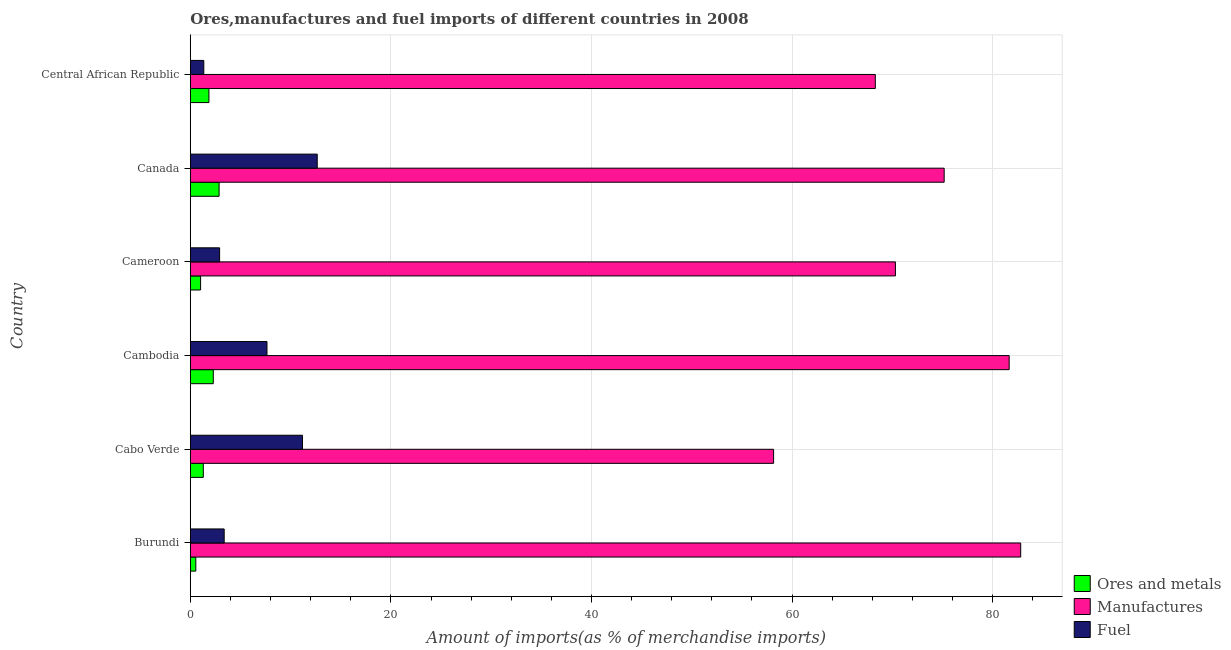How many groups of bars are there?
Offer a terse response. 6. Are the number of bars per tick equal to the number of legend labels?
Provide a succinct answer. Yes. How many bars are there on the 5th tick from the top?
Provide a short and direct response. 3. How many bars are there on the 1st tick from the bottom?
Ensure brevity in your answer.  3. What is the label of the 6th group of bars from the top?
Offer a terse response. Burundi. What is the percentage of fuel imports in Burundi?
Offer a very short reply. 3.38. Across all countries, what is the maximum percentage of manufactures imports?
Make the answer very short. 82.8. Across all countries, what is the minimum percentage of manufactures imports?
Provide a short and direct response. 58.16. In which country was the percentage of manufactures imports maximum?
Your answer should be very brief. Burundi. In which country was the percentage of fuel imports minimum?
Provide a short and direct response. Central African Republic. What is the total percentage of fuel imports in the graph?
Provide a succinct answer. 39.14. What is the difference between the percentage of fuel imports in Burundi and that in Cabo Verde?
Ensure brevity in your answer.  -7.81. What is the difference between the percentage of manufactures imports in Central African Republic and the percentage of ores and metals imports in Canada?
Offer a very short reply. 65.43. What is the average percentage of fuel imports per country?
Your answer should be very brief. 6.52. What is the difference between the percentage of ores and metals imports and percentage of manufactures imports in Cabo Verde?
Your response must be concise. -56.86. What is the ratio of the percentage of manufactures imports in Burundi to that in Cabo Verde?
Give a very brief answer. 1.42. Is the percentage of fuel imports in Cameroon less than that in Central African Republic?
Give a very brief answer. No. Is the difference between the percentage of manufactures imports in Burundi and Cameroon greater than the difference between the percentage of ores and metals imports in Burundi and Cameroon?
Your response must be concise. Yes. What is the difference between the highest and the second highest percentage of fuel imports?
Your response must be concise. 1.47. What is the difference between the highest and the lowest percentage of manufactures imports?
Provide a succinct answer. 24.64. What does the 3rd bar from the top in Canada represents?
Ensure brevity in your answer.  Ores and metals. What does the 3rd bar from the bottom in Canada represents?
Provide a succinct answer. Fuel. Is it the case that in every country, the sum of the percentage of ores and metals imports and percentage of manufactures imports is greater than the percentage of fuel imports?
Your answer should be very brief. Yes. Are all the bars in the graph horizontal?
Your answer should be compact. Yes. What is the difference between two consecutive major ticks on the X-axis?
Keep it short and to the point. 20. Are the values on the major ticks of X-axis written in scientific E-notation?
Offer a very short reply. No. Does the graph contain any zero values?
Your response must be concise. No. What is the title of the graph?
Offer a terse response. Ores,manufactures and fuel imports of different countries in 2008. Does "Oil sources" appear as one of the legend labels in the graph?
Your response must be concise. No. What is the label or title of the X-axis?
Provide a succinct answer. Amount of imports(as % of merchandise imports). What is the Amount of imports(as % of merchandise imports) of Ores and metals in Burundi?
Provide a short and direct response. 0.55. What is the Amount of imports(as % of merchandise imports) of Manufactures in Burundi?
Your answer should be compact. 82.8. What is the Amount of imports(as % of merchandise imports) in Fuel in Burundi?
Offer a terse response. 3.38. What is the Amount of imports(as % of merchandise imports) in Ores and metals in Cabo Verde?
Offer a very short reply. 1.3. What is the Amount of imports(as % of merchandise imports) of Manufactures in Cabo Verde?
Your answer should be compact. 58.16. What is the Amount of imports(as % of merchandise imports) in Fuel in Cabo Verde?
Keep it short and to the point. 11.19. What is the Amount of imports(as % of merchandise imports) in Ores and metals in Cambodia?
Make the answer very short. 2.29. What is the Amount of imports(as % of merchandise imports) in Manufactures in Cambodia?
Your answer should be very brief. 81.65. What is the Amount of imports(as % of merchandise imports) of Fuel in Cambodia?
Your response must be concise. 7.65. What is the Amount of imports(as % of merchandise imports) of Ores and metals in Cameroon?
Make the answer very short. 1.03. What is the Amount of imports(as % of merchandise imports) in Manufactures in Cameroon?
Your response must be concise. 70.31. What is the Amount of imports(as % of merchandise imports) in Fuel in Cameroon?
Ensure brevity in your answer.  2.92. What is the Amount of imports(as % of merchandise imports) in Ores and metals in Canada?
Your answer should be compact. 2.87. What is the Amount of imports(as % of merchandise imports) in Manufactures in Canada?
Keep it short and to the point. 75.17. What is the Amount of imports(as % of merchandise imports) of Fuel in Canada?
Keep it short and to the point. 12.66. What is the Amount of imports(as % of merchandise imports) in Ores and metals in Central African Republic?
Make the answer very short. 1.86. What is the Amount of imports(as % of merchandise imports) in Manufactures in Central African Republic?
Make the answer very short. 68.3. What is the Amount of imports(as % of merchandise imports) in Fuel in Central African Republic?
Provide a short and direct response. 1.35. Across all countries, what is the maximum Amount of imports(as % of merchandise imports) of Ores and metals?
Give a very brief answer. 2.87. Across all countries, what is the maximum Amount of imports(as % of merchandise imports) in Manufactures?
Provide a short and direct response. 82.8. Across all countries, what is the maximum Amount of imports(as % of merchandise imports) in Fuel?
Give a very brief answer. 12.66. Across all countries, what is the minimum Amount of imports(as % of merchandise imports) in Ores and metals?
Make the answer very short. 0.55. Across all countries, what is the minimum Amount of imports(as % of merchandise imports) of Manufactures?
Offer a very short reply. 58.16. Across all countries, what is the minimum Amount of imports(as % of merchandise imports) in Fuel?
Offer a terse response. 1.35. What is the total Amount of imports(as % of merchandise imports) in Ores and metals in the graph?
Offer a terse response. 9.9. What is the total Amount of imports(as % of merchandise imports) of Manufactures in the graph?
Keep it short and to the point. 436.39. What is the total Amount of imports(as % of merchandise imports) of Fuel in the graph?
Provide a succinct answer. 39.14. What is the difference between the Amount of imports(as % of merchandise imports) in Ores and metals in Burundi and that in Cabo Verde?
Your answer should be compact. -0.75. What is the difference between the Amount of imports(as % of merchandise imports) in Manufactures in Burundi and that in Cabo Verde?
Make the answer very short. 24.64. What is the difference between the Amount of imports(as % of merchandise imports) in Fuel in Burundi and that in Cabo Verde?
Provide a succinct answer. -7.81. What is the difference between the Amount of imports(as % of merchandise imports) in Ores and metals in Burundi and that in Cambodia?
Make the answer very short. -1.74. What is the difference between the Amount of imports(as % of merchandise imports) of Manufactures in Burundi and that in Cambodia?
Ensure brevity in your answer.  1.15. What is the difference between the Amount of imports(as % of merchandise imports) of Fuel in Burundi and that in Cambodia?
Offer a terse response. -4.27. What is the difference between the Amount of imports(as % of merchandise imports) in Ores and metals in Burundi and that in Cameroon?
Provide a succinct answer. -0.48. What is the difference between the Amount of imports(as % of merchandise imports) of Manufactures in Burundi and that in Cameroon?
Your answer should be compact. 12.49. What is the difference between the Amount of imports(as % of merchandise imports) in Fuel in Burundi and that in Cameroon?
Keep it short and to the point. 0.46. What is the difference between the Amount of imports(as % of merchandise imports) in Ores and metals in Burundi and that in Canada?
Give a very brief answer. -2.32. What is the difference between the Amount of imports(as % of merchandise imports) in Manufactures in Burundi and that in Canada?
Your answer should be very brief. 7.63. What is the difference between the Amount of imports(as % of merchandise imports) in Fuel in Burundi and that in Canada?
Your response must be concise. -9.28. What is the difference between the Amount of imports(as % of merchandise imports) in Ores and metals in Burundi and that in Central African Republic?
Your answer should be compact. -1.31. What is the difference between the Amount of imports(as % of merchandise imports) in Manufactures in Burundi and that in Central African Republic?
Keep it short and to the point. 14.49. What is the difference between the Amount of imports(as % of merchandise imports) of Fuel in Burundi and that in Central African Republic?
Provide a succinct answer. 2.03. What is the difference between the Amount of imports(as % of merchandise imports) in Ores and metals in Cabo Verde and that in Cambodia?
Offer a very short reply. -0.99. What is the difference between the Amount of imports(as % of merchandise imports) of Manufactures in Cabo Verde and that in Cambodia?
Give a very brief answer. -23.49. What is the difference between the Amount of imports(as % of merchandise imports) of Fuel in Cabo Verde and that in Cambodia?
Your response must be concise. 3.54. What is the difference between the Amount of imports(as % of merchandise imports) of Ores and metals in Cabo Verde and that in Cameroon?
Your response must be concise. 0.27. What is the difference between the Amount of imports(as % of merchandise imports) of Manufactures in Cabo Verde and that in Cameroon?
Make the answer very short. -12.15. What is the difference between the Amount of imports(as % of merchandise imports) in Fuel in Cabo Verde and that in Cameroon?
Provide a short and direct response. 8.26. What is the difference between the Amount of imports(as % of merchandise imports) in Ores and metals in Cabo Verde and that in Canada?
Offer a terse response. -1.57. What is the difference between the Amount of imports(as % of merchandise imports) in Manufactures in Cabo Verde and that in Canada?
Your response must be concise. -17.01. What is the difference between the Amount of imports(as % of merchandise imports) in Fuel in Cabo Verde and that in Canada?
Provide a short and direct response. -1.47. What is the difference between the Amount of imports(as % of merchandise imports) in Ores and metals in Cabo Verde and that in Central African Republic?
Give a very brief answer. -0.56. What is the difference between the Amount of imports(as % of merchandise imports) in Manufactures in Cabo Verde and that in Central African Republic?
Ensure brevity in your answer.  -10.14. What is the difference between the Amount of imports(as % of merchandise imports) of Fuel in Cabo Verde and that in Central African Republic?
Your answer should be compact. 9.84. What is the difference between the Amount of imports(as % of merchandise imports) of Ores and metals in Cambodia and that in Cameroon?
Your answer should be very brief. 1.27. What is the difference between the Amount of imports(as % of merchandise imports) in Manufactures in Cambodia and that in Cameroon?
Your answer should be compact. 11.34. What is the difference between the Amount of imports(as % of merchandise imports) of Fuel in Cambodia and that in Cameroon?
Ensure brevity in your answer.  4.72. What is the difference between the Amount of imports(as % of merchandise imports) in Ores and metals in Cambodia and that in Canada?
Offer a very short reply. -0.58. What is the difference between the Amount of imports(as % of merchandise imports) in Manufactures in Cambodia and that in Canada?
Offer a very short reply. 6.48. What is the difference between the Amount of imports(as % of merchandise imports) of Fuel in Cambodia and that in Canada?
Provide a succinct answer. -5.01. What is the difference between the Amount of imports(as % of merchandise imports) of Ores and metals in Cambodia and that in Central African Republic?
Your response must be concise. 0.44. What is the difference between the Amount of imports(as % of merchandise imports) of Manufactures in Cambodia and that in Central African Republic?
Offer a terse response. 13.34. What is the difference between the Amount of imports(as % of merchandise imports) in Fuel in Cambodia and that in Central African Republic?
Provide a short and direct response. 6.3. What is the difference between the Amount of imports(as % of merchandise imports) in Ores and metals in Cameroon and that in Canada?
Give a very brief answer. -1.85. What is the difference between the Amount of imports(as % of merchandise imports) in Manufactures in Cameroon and that in Canada?
Your answer should be compact. -4.86. What is the difference between the Amount of imports(as % of merchandise imports) of Fuel in Cameroon and that in Canada?
Keep it short and to the point. -9.73. What is the difference between the Amount of imports(as % of merchandise imports) of Ores and metals in Cameroon and that in Central African Republic?
Your response must be concise. -0.83. What is the difference between the Amount of imports(as % of merchandise imports) of Manufactures in Cameroon and that in Central African Republic?
Your answer should be compact. 2. What is the difference between the Amount of imports(as % of merchandise imports) in Fuel in Cameroon and that in Central African Republic?
Offer a terse response. 1.58. What is the difference between the Amount of imports(as % of merchandise imports) in Ores and metals in Canada and that in Central African Republic?
Provide a succinct answer. 1.01. What is the difference between the Amount of imports(as % of merchandise imports) of Manufactures in Canada and that in Central African Republic?
Your response must be concise. 6.86. What is the difference between the Amount of imports(as % of merchandise imports) in Fuel in Canada and that in Central African Republic?
Make the answer very short. 11.31. What is the difference between the Amount of imports(as % of merchandise imports) in Ores and metals in Burundi and the Amount of imports(as % of merchandise imports) in Manufactures in Cabo Verde?
Your answer should be very brief. -57.61. What is the difference between the Amount of imports(as % of merchandise imports) of Ores and metals in Burundi and the Amount of imports(as % of merchandise imports) of Fuel in Cabo Verde?
Your answer should be very brief. -10.64. What is the difference between the Amount of imports(as % of merchandise imports) in Manufactures in Burundi and the Amount of imports(as % of merchandise imports) in Fuel in Cabo Verde?
Provide a short and direct response. 71.61. What is the difference between the Amount of imports(as % of merchandise imports) in Ores and metals in Burundi and the Amount of imports(as % of merchandise imports) in Manufactures in Cambodia?
Provide a short and direct response. -81.1. What is the difference between the Amount of imports(as % of merchandise imports) of Ores and metals in Burundi and the Amount of imports(as % of merchandise imports) of Fuel in Cambodia?
Provide a succinct answer. -7.1. What is the difference between the Amount of imports(as % of merchandise imports) in Manufactures in Burundi and the Amount of imports(as % of merchandise imports) in Fuel in Cambodia?
Offer a very short reply. 75.15. What is the difference between the Amount of imports(as % of merchandise imports) of Ores and metals in Burundi and the Amount of imports(as % of merchandise imports) of Manufactures in Cameroon?
Provide a succinct answer. -69.76. What is the difference between the Amount of imports(as % of merchandise imports) in Ores and metals in Burundi and the Amount of imports(as % of merchandise imports) in Fuel in Cameroon?
Provide a succinct answer. -2.37. What is the difference between the Amount of imports(as % of merchandise imports) of Manufactures in Burundi and the Amount of imports(as % of merchandise imports) of Fuel in Cameroon?
Offer a terse response. 79.88. What is the difference between the Amount of imports(as % of merchandise imports) in Ores and metals in Burundi and the Amount of imports(as % of merchandise imports) in Manufactures in Canada?
Your answer should be very brief. -74.62. What is the difference between the Amount of imports(as % of merchandise imports) of Ores and metals in Burundi and the Amount of imports(as % of merchandise imports) of Fuel in Canada?
Your answer should be compact. -12.11. What is the difference between the Amount of imports(as % of merchandise imports) of Manufactures in Burundi and the Amount of imports(as % of merchandise imports) of Fuel in Canada?
Offer a very short reply. 70.14. What is the difference between the Amount of imports(as % of merchandise imports) of Ores and metals in Burundi and the Amount of imports(as % of merchandise imports) of Manufactures in Central African Republic?
Give a very brief answer. -67.75. What is the difference between the Amount of imports(as % of merchandise imports) of Ores and metals in Burundi and the Amount of imports(as % of merchandise imports) of Fuel in Central African Republic?
Ensure brevity in your answer.  -0.8. What is the difference between the Amount of imports(as % of merchandise imports) of Manufactures in Burundi and the Amount of imports(as % of merchandise imports) of Fuel in Central African Republic?
Make the answer very short. 81.45. What is the difference between the Amount of imports(as % of merchandise imports) of Ores and metals in Cabo Verde and the Amount of imports(as % of merchandise imports) of Manufactures in Cambodia?
Offer a terse response. -80.35. What is the difference between the Amount of imports(as % of merchandise imports) of Ores and metals in Cabo Verde and the Amount of imports(as % of merchandise imports) of Fuel in Cambodia?
Give a very brief answer. -6.35. What is the difference between the Amount of imports(as % of merchandise imports) of Manufactures in Cabo Verde and the Amount of imports(as % of merchandise imports) of Fuel in Cambodia?
Offer a very short reply. 50.51. What is the difference between the Amount of imports(as % of merchandise imports) in Ores and metals in Cabo Verde and the Amount of imports(as % of merchandise imports) in Manufactures in Cameroon?
Give a very brief answer. -69.01. What is the difference between the Amount of imports(as % of merchandise imports) of Ores and metals in Cabo Verde and the Amount of imports(as % of merchandise imports) of Fuel in Cameroon?
Provide a short and direct response. -1.63. What is the difference between the Amount of imports(as % of merchandise imports) in Manufactures in Cabo Verde and the Amount of imports(as % of merchandise imports) in Fuel in Cameroon?
Provide a short and direct response. 55.24. What is the difference between the Amount of imports(as % of merchandise imports) in Ores and metals in Cabo Verde and the Amount of imports(as % of merchandise imports) in Manufactures in Canada?
Offer a terse response. -73.87. What is the difference between the Amount of imports(as % of merchandise imports) of Ores and metals in Cabo Verde and the Amount of imports(as % of merchandise imports) of Fuel in Canada?
Give a very brief answer. -11.36. What is the difference between the Amount of imports(as % of merchandise imports) in Manufactures in Cabo Verde and the Amount of imports(as % of merchandise imports) in Fuel in Canada?
Offer a terse response. 45.5. What is the difference between the Amount of imports(as % of merchandise imports) of Ores and metals in Cabo Verde and the Amount of imports(as % of merchandise imports) of Manufactures in Central African Republic?
Give a very brief answer. -67.01. What is the difference between the Amount of imports(as % of merchandise imports) in Ores and metals in Cabo Verde and the Amount of imports(as % of merchandise imports) in Fuel in Central African Republic?
Offer a terse response. -0.05. What is the difference between the Amount of imports(as % of merchandise imports) in Manufactures in Cabo Verde and the Amount of imports(as % of merchandise imports) in Fuel in Central African Republic?
Provide a short and direct response. 56.81. What is the difference between the Amount of imports(as % of merchandise imports) in Ores and metals in Cambodia and the Amount of imports(as % of merchandise imports) in Manufactures in Cameroon?
Make the answer very short. -68.02. What is the difference between the Amount of imports(as % of merchandise imports) of Ores and metals in Cambodia and the Amount of imports(as % of merchandise imports) of Fuel in Cameroon?
Provide a succinct answer. -0.63. What is the difference between the Amount of imports(as % of merchandise imports) of Manufactures in Cambodia and the Amount of imports(as % of merchandise imports) of Fuel in Cameroon?
Your answer should be very brief. 78.73. What is the difference between the Amount of imports(as % of merchandise imports) of Ores and metals in Cambodia and the Amount of imports(as % of merchandise imports) of Manufactures in Canada?
Give a very brief answer. -72.88. What is the difference between the Amount of imports(as % of merchandise imports) in Ores and metals in Cambodia and the Amount of imports(as % of merchandise imports) in Fuel in Canada?
Provide a short and direct response. -10.37. What is the difference between the Amount of imports(as % of merchandise imports) in Manufactures in Cambodia and the Amount of imports(as % of merchandise imports) in Fuel in Canada?
Your answer should be compact. 68.99. What is the difference between the Amount of imports(as % of merchandise imports) of Ores and metals in Cambodia and the Amount of imports(as % of merchandise imports) of Manufactures in Central African Republic?
Provide a succinct answer. -66.01. What is the difference between the Amount of imports(as % of merchandise imports) of Ores and metals in Cambodia and the Amount of imports(as % of merchandise imports) of Fuel in Central African Republic?
Provide a short and direct response. 0.95. What is the difference between the Amount of imports(as % of merchandise imports) in Manufactures in Cambodia and the Amount of imports(as % of merchandise imports) in Fuel in Central African Republic?
Give a very brief answer. 80.3. What is the difference between the Amount of imports(as % of merchandise imports) in Ores and metals in Cameroon and the Amount of imports(as % of merchandise imports) in Manufactures in Canada?
Keep it short and to the point. -74.14. What is the difference between the Amount of imports(as % of merchandise imports) in Ores and metals in Cameroon and the Amount of imports(as % of merchandise imports) in Fuel in Canada?
Provide a short and direct response. -11.63. What is the difference between the Amount of imports(as % of merchandise imports) in Manufactures in Cameroon and the Amount of imports(as % of merchandise imports) in Fuel in Canada?
Offer a terse response. 57.65. What is the difference between the Amount of imports(as % of merchandise imports) in Ores and metals in Cameroon and the Amount of imports(as % of merchandise imports) in Manufactures in Central African Republic?
Make the answer very short. -67.28. What is the difference between the Amount of imports(as % of merchandise imports) of Ores and metals in Cameroon and the Amount of imports(as % of merchandise imports) of Fuel in Central African Republic?
Your answer should be compact. -0.32. What is the difference between the Amount of imports(as % of merchandise imports) of Manufactures in Cameroon and the Amount of imports(as % of merchandise imports) of Fuel in Central African Republic?
Your answer should be very brief. 68.96. What is the difference between the Amount of imports(as % of merchandise imports) in Ores and metals in Canada and the Amount of imports(as % of merchandise imports) in Manufactures in Central African Republic?
Give a very brief answer. -65.43. What is the difference between the Amount of imports(as % of merchandise imports) of Ores and metals in Canada and the Amount of imports(as % of merchandise imports) of Fuel in Central African Republic?
Provide a short and direct response. 1.52. What is the difference between the Amount of imports(as % of merchandise imports) in Manufactures in Canada and the Amount of imports(as % of merchandise imports) in Fuel in Central African Republic?
Ensure brevity in your answer.  73.82. What is the average Amount of imports(as % of merchandise imports) of Ores and metals per country?
Keep it short and to the point. 1.65. What is the average Amount of imports(as % of merchandise imports) of Manufactures per country?
Your answer should be very brief. 72.73. What is the average Amount of imports(as % of merchandise imports) of Fuel per country?
Provide a succinct answer. 6.52. What is the difference between the Amount of imports(as % of merchandise imports) in Ores and metals and Amount of imports(as % of merchandise imports) in Manufactures in Burundi?
Your answer should be compact. -82.25. What is the difference between the Amount of imports(as % of merchandise imports) in Ores and metals and Amount of imports(as % of merchandise imports) in Fuel in Burundi?
Keep it short and to the point. -2.83. What is the difference between the Amount of imports(as % of merchandise imports) in Manufactures and Amount of imports(as % of merchandise imports) in Fuel in Burundi?
Your response must be concise. 79.42. What is the difference between the Amount of imports(as % of merchandise imports) of Ores and metals and Amount of imports(as % of merchandise imports) of Manufactures in Cabo Verde?
Your answer should be compact. -56.86. What is the difference between the Amount of imports(as % of merchandise imports) of Ores and metals and Amount of imports(as % of merchandise imports) of Fuel in Cabo Verde?
Offer a very short reply. -9.89. What is the difference between the Amount of imports(as % of merchandise imports) of Manufactures and Amount of imports(as % of merchandise imports) of Fuel in Cabo Verde?
Ensure brevity in your answer.  46.97. What is the difference between the Amount of imports(as % of merchandise imports) in Ores and metals and Amount of imports(as % of merchandise imports) in Manufactures in Cambodia?
Ensure brevity in your answer.  -79.36. What is the difference between the Amount of imports(as % of merchandise imports) of Ores and metals and Amount of imports(as % of merchandise imports) of Fuel in Cambodia?
Your answer should be very brief. -5.35. What is the difference between the Amount of imports(as % of merchandise imports) of Manufactures and Amount of imports(as % of merchandise imports) of Fuel in Cambodia?
Your response must be concise. 74. What is the difference between the Amount of imports(as % of merchandise imports) in Ores and metals and Amount of imports(as % of merchandise imports) in Manufactures in Cameroon?
Offer a terse response. -69.28. What is the difference between the Amount of imports(as % of merchandise imports) of Ores and metals and Amount of imports(as % of merchandise imports) of Fuel in Cameroon?
Your answer should be compact. -1.9. What is the difference between the Amount of imports(as % of merchandise imports) in Manufactures and Amount of imports(as % of merchandise imports) in Fuel in Cameroon?
Offer a terse response. 67.38. What is the difference between the Amount of imports(as % of merchandise imports) of Ores and metals and Amount of imports(as % of merchandise imports) of Manufactures in Canada?
Your answer should be compact. -72.3. What is the difference between the Amount of imports(as % of merchandise imports) of Ores and metals and Amount of imports(as % of merchandise imports) of Fuel in Canada?
Make the answer very short. -9.79. What is the difference between the Amount of imports(as % of merchandise imports) in Manufactures and Amount of imports(as % of merchandise imports) in Fuel in Canada?
Your response must be concise. 62.51. What is the difference between the Amount of imports(as % of merchandise imports) of Ores and metals and Amount of imports(as % of merchandise imports) of Manufactures in Central African Republic?
Your answer should be compact. -66.45. What is the difference between the Amount of imports(as % of merchandise imports) of Ores and metals and Amount of imports(as % of merchandise imports) of Fuel in Central African Republic?
Your answer should be compact. 0.51. What is the difference between the Amount of imports(as % of merchandise imports) in Manufactures and Amount of imports(as % of merchandise imports) in Fuel in Central African Republic?
Your response must be concise. 66.96. What is the ratio of the Amount of imports(as % of merchandise imports) in Ores and metals in Burundi to that in Cabo Verde?
Offer a terse response. 0.42. What is the ratio of the Amount of imports(as % of merchandise imports) of Manufactures in Burundi to that in Cabo Verde?
Make the answer very short. 1.42. What is the ratio of the Amount of imports(as % of merchandise imports) in Fuel in Burundi to that in Cabo Verde?
Provide a short and direct response. 0.3. What is the ratio of the Amount of imports(as % of merchandise imports) of Ores and metals in Burundi to that in Cambodia?
Give a very brief answer. 0.24. What is the ratio of the Amount of imports(as % of merchandise imports) in Manufactures in Burundi to that in Cambodia?
Provide a short and direct response. 1.01. What is the ratio of the Amount of imports(as % of merchandise imports) of Fuel in Burundi to that in Cambodia?
Provide a short and direct response. 0.44. What is the ratio of the Amount of imports(as % of merchandise imports) of Ores and metals in Burundi to that in Cameroon?
Keep it short and to the point. 0.54. What is the ratio of the Amount of imports(as % of merchandise imports) in Manufactures in Burundi to that in Cameroon?
Offer a terse response. 1.18. What is the ratio of the Amount of imports(as % of merchandise imports) in Fuel in Burundi to that in Cameroon?
Provide a short and direct response. 1.16. What is the ratio of the Amount of imports(as % of merchandise imports) of Ores and metals in Burundi to that in Canada?
Offer a very short reply. 0.19. What is the ratio of the Amount of imports(as % of merchandise imports) in Manufactures in Burundi to that in Canada?
Your answer should be very brief. 1.1. What is the ratio of the Amount of imports(as % of merchandise imports) of Fuel in Burundi to that in Canada?
Offer a terse response. 0.27. What is the ratio of the Amount of imports(as % of merchandise imports) of Ores and metals in Burundi to that in Central African Republic?
Ensure brevity in your answer.  0.3. What is the ratio of the Amount of imports(as % of merchandise imports) in Manufactures in Burundi to that in Central African Republic?
Your answer should be compact. 1.21. What is the ratio of the Amount of imports(as % of merchandise imports) in Fuel in Burundi to that in Central African Republic?
Your answer should be very brief. 2.51. What is the ratio of the Amount of imports(as % of merchandise imports) in Ores and metals in Cabo Verde to that in Cambodia?
Provide a succinct answer. 0.57. What is the ratio of the Amount of imports(as % of merchandise imports) of Manufactures in Cabo Verde to that in Cambodia?
Give a very brief answer. 0.71. What is the ratio of the Amount of imports(as % of merchandise imports) of Fuel in Cabo Verde to that in Cambodia?
Give a very brief answer. 1.46. What is the ratio of the Amount of imports(as % of merchandise imports) in Ores and metals in Cabo Verde to that in Cameroon?
Your answer should be compact. 1.26. What is the ratio of the Amount of imports(as % of merchandise imports) of Manufactures in Cabo Verde to that in Cameroon?
Your answer should be very brief. 0.83. What is the ratio of the Amount of imports(as % of merchandise imports) in Fuel in Cabo Verde to that in Cameroon?
Offer a terse response. 3.83. What is the ratio of the Amount of imports(as % of merchandise imports) of Ores and metals in Cabo Verde to that in Canada?
Ensure brevity in your answer.  0.45. What is the ratio of the Amount of imports(as % of merchandise imports) in Manufactures in Cabo Verde to that in Canada?
Your answer should be very brief. 0.77. What is the ratio of the Amount of imports(as % of merchandise imports) in Fuel in Cabo Verde to that in Canada?
Provide a short and direct response. 0.88. What is the ratio of the Amount of imports(as % of merchandise imports) of Ores and metals in Cabo Verde to that in Central African Republic?
Your answer should be compact. 0.7. What is the ratio of the Amount of imports(as % of merchandise imports) of Manufactures in Cabo Verde to that in Central African Republic?
Your answer should be very brief. 0.85. What is the ratio of the Amount of imports(as % of merchandise imports) of Fuel in Cabo Verde to that in Central African Republic?
Make the answer very short. 8.3. What is the ratio of the Amount of imports(as % of merchandise imports) in Ores and metals in Cambodia to that in Cameroon?
Provide a succinct answer. 2.23. What is the ratio of the Amount of imports(as % of merchandise imports) of Manufactures in Cambodia to that in Cameroon?
Provide a succinct answer. 1.16. What is the ratio of the Amount of imports(as % of merchandise imports) in Fuel in Cambodia to that in Cameroon?
Keep it short and to the point. 2.62. What is the ratio of the Amount of imports(as % of merchandise imports) in Ores and metals in Cambodia to that in Canada?
Provide a short and direct response. 0.8. What is the ratio of the Amount of imports(as % of merchandise imports) in Manufactures in Cambodia to that in Canada?
Your answer should be very brief. 1.09. What is the ratio of the Amount of imports(as % of merchandise imports) in Fuel in Cambodia to that in Canada?
Provide a short and direct response. 0.6. What is the ratio of the Amount of imports(as % of merchandise imports) in Ores and metals in Cambodia to that in Central African Republic?
Give a very brief answer. 1.23. What is the ratio of the Amount of imports(as % of merchandise imports) of Manufactures in Cambodia to that in Central African Republic?
Your answer should be compact. 1.2. What is the ratio of the Amount of imports(as % of merchandise imports) of Fuel in Cambodia to that in Central African Republic?
Provide a short and direct response. 5.68. What is the ratio of the Amount of imports(as % of merchandise imports) of Ores and metals in Cameroon to that in Canada?
Your answer should be very brief. 0.36. What is the ratio of the Amount of imports(as % of merchandise imports) of Manufactures in Cameroon to that in Canada?
Give a very brief answer. 0.94. What is the ratio of the Amount of imports(as % of merchandise imports) in Fuel in Cameroon to that in Canada?
Provide a short and direct response. 0.23. What is the ratio of the Amount of imports(as % of merchandise imports) in Ores and metals in Cameroon to that in Central African Republic?
Offer a very short reply. 0.55. What is the ratio of the Amount of imports(as % of merchandise imports) of Manufactures in Cameroon to that in Central African Republic?
Offer a very short reply. 1.03. What is the ratio of the Amount of imports(as % of merchandise imports) of Fuel in Cameroon to that in Central African Republic?
Ensure brevity in your answer.  2.17. What is the ratio of the Amount of imports(as % of merchandise imports) of Ores and metals in Canada to that in Central African Republic?
Offer a terse response. 1.55. What is the ratio of the Amount of imports(as % of merchandise imports) of Manufactures in Canada to that in Central African Republic?
Give a very brief answer. 1.1. What is the ratio of the Amount of imports(as % of merchandise imports) of Fuel in Canada to that in Central African Republic?
Ensure brevity in your answer.  9.4. What is the difference between the highest and the second highest Amount of imports(as % of merchandise imports) in Ores and metals?
Provide a succinct answer. 0.58. What is the difference between the highest and the second highest Amount of imports(as % of merchandise imports) of Manufactures?
Ensure brevity in your answer.  1.15. What is the difference between the highest and the second highest Amount of imports(as % of merchandise imports) in Fuel?
Offer a very short reply. 1.47. What is the difference between the highest and the lowest Amount of imports(as % of merchandise imports) of Ores and metals?
Provide a short and direct response. 2.32. What is the difference between the highest and the lowest Amount of imports(as % of merchandise imports) of Manufactures?
Your answer should be very brief. 24.64. What is the difference between the highest and the lowest Amount of imports(as % of merchandise imports) of Fuel?
Your response must be concise. 11.31. 